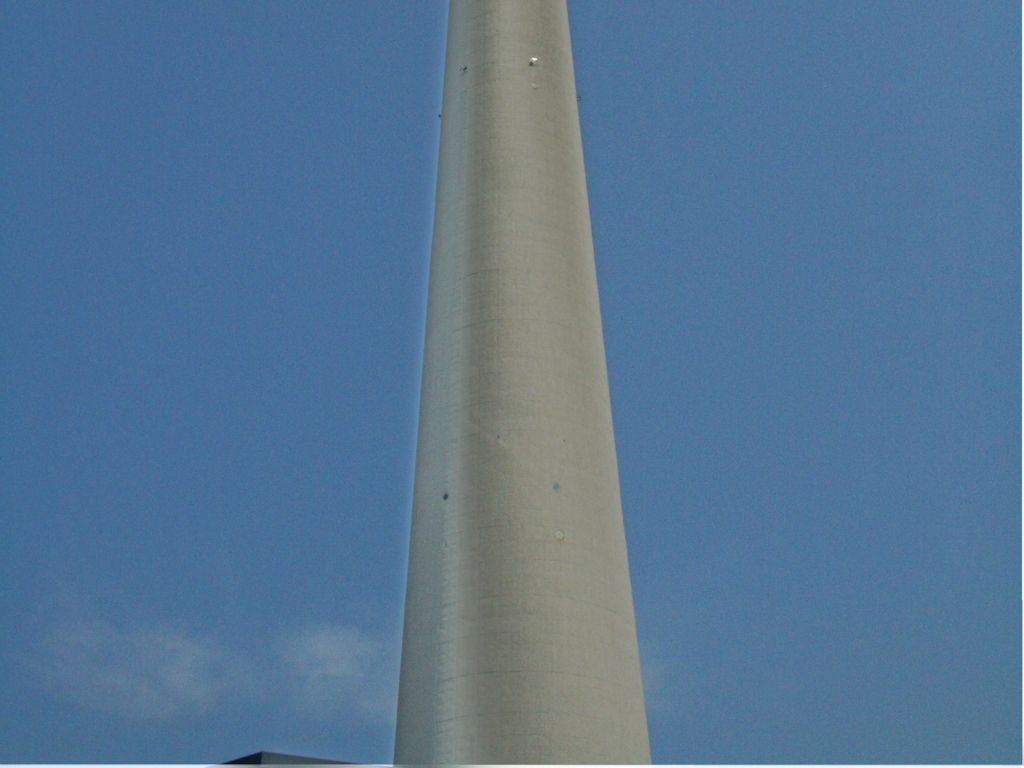What kind of structure is shown in this image, and can any details about its function be gleaned? The image shows a tall, cylindrical concrete structure that could be part of a tower, chimney, or large pole. Without additional context, its exact function is difficult to determine, but it could be related to an industrial facility, a monument, or a utility infrastructure. 